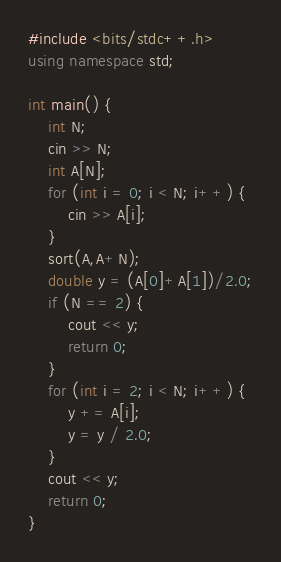<code> <loc_0><loc_0><loc_500><loc_500><_C++_>#include <bits/stdc++.h>
using namespace std;

int main() {
    int N;
    cin >> N;
    int A[N];
    for (int i = 0; i < N; i++) {
        cin >> A[i];
    }
    sort(A,A+N);
    double y = (A[0]+A[1])/2.0;
    if (N == 2) {
        cout << y;
        return 0;
    }
    for (int i = 2; i < N; i++) {
        y += A[i];
        y = y / 2.0;
    }
    cout << y;
    return 0;
}</code> 